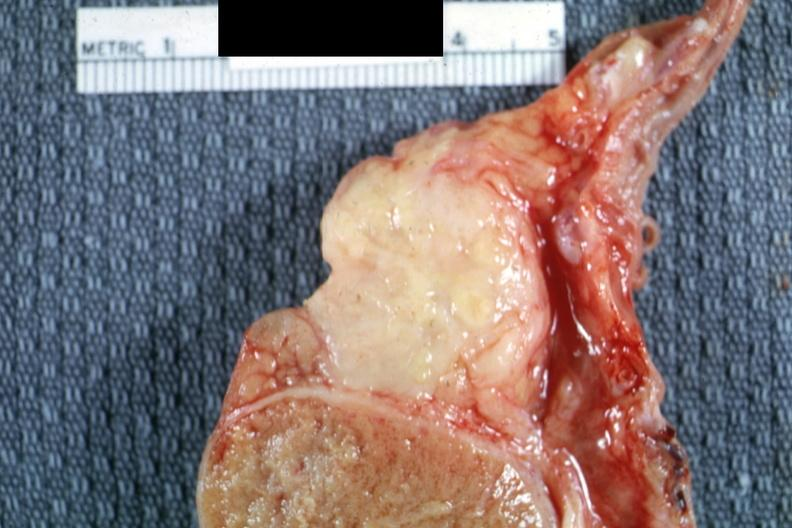s epididymis present?
Answer the question using a single word or phrase. Yes 